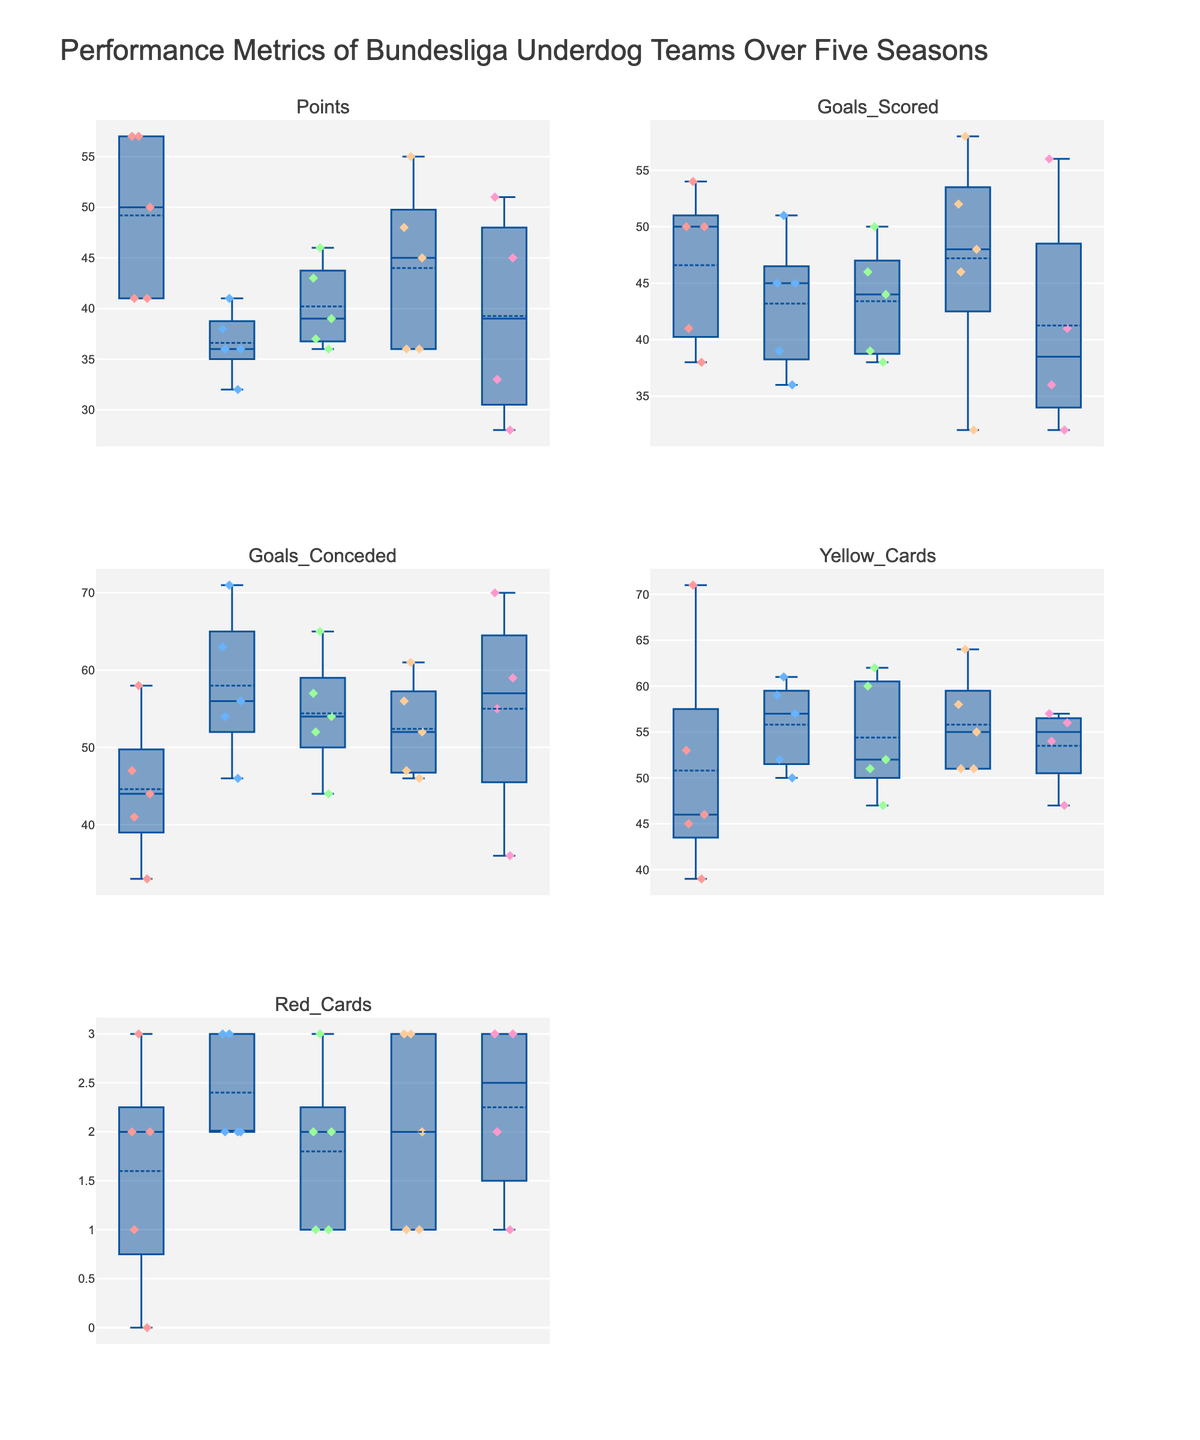How many teams are visualized in the figure? There are box plots for each of the teams shown in the subplots for each metric. Counting the unique boxes in any subplot will give us the number of teams.
Answer: 5 Which team has the highest median value for goals scored? Locate the subplot for "Goals Scored" and identify the box plot with the highest median line (distance from the bottom of the box).
Answer: Freiburg Which team received the most red cards in the 2020/2021 season? Go to the subplot for "Red Cards" and identify the box plot with the highest value in the 2020/2021 data points by examining the individual points.
Answer: Stuttgart Compare Union Berlin and Augsburg in terms of the median number of yellow cards. Which team has a higher median value? In the "Yellow Cards" subplot, compare the median lines (middle lines inside the boxes) of Union Berlin and Augsburg.
Answer: Union Berlin What's the median value for points scored by Freiburg? Identify the "Points" subplot, locate Freiburg's box plot, and look at the median line inside the box.
Answer: 45 Which team appears to have the most variability in goals conceded over the five seasons? In the "Goals Conceded" subplot, look for the box plot with the widest interval (distance between the top and bottom of the box).
Answer: Union Berlin What's the interquartile range (IQR) for yellow cards received by Mainz? Locate Mainz’s box plot in the "Yellow Cards" subplot. The IQR is the distance between the third quartile (top of the box) and the first quartile (bottom of the box). Calculate the difference between these two values.
Answer: 12 Which team has the least variability in points scored, and how can you tell? Identify the "Points" subplot and look for the box plot with the smallest interquartile range (size of the box).
Answer: Stuttgart How does the range of goals scored by Stuttgart compare to Union Berlin? In the "Goals Scored" subplot, compare the range (distance from the minimum to the maximum value) of Stuttgart's and Union Berlin's box plots. Note which range is larger.
Answer: Stuttgart has a larger range Among the metrics visualized, which one shows the least overall variability across all teams? Compare the sizes of the boxes across all subplots. Identify the subplot where most boxes have smaller heights, indicating less variation.
Answer: Points 